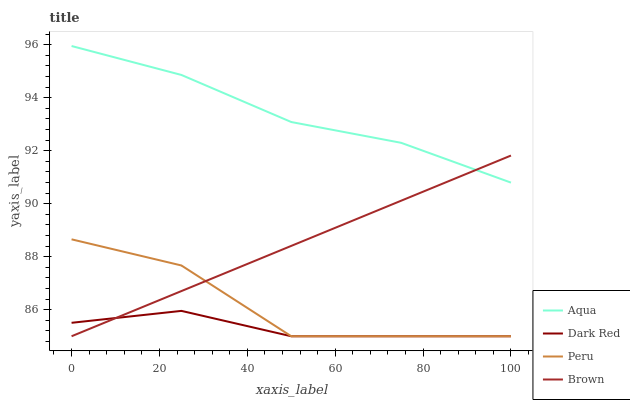Does Dark Red have the minimum area under the curve?
Answer yes or no. Yes. Does Aqua have the maximum area under the curve?
Answer yes or no. Yes. Does Peru have the minimum area under the curve?
Answer yes or no. No. Does Peru have the maximum area under the curve?
Answer yes or no. No. Is Brown the smoothest?
Answer yes or no. Yes. Is Peru the roughest?
Answer yes or no. Yes. Is Aqua the smoothest?
Answer yes or no. No. Is Aqua the roughest?
Answer yes or no. No. Does Dark Red have the lowest value?
Answer yes or no. Yes. Does Aqua have the lowest value?
Answer yes or no. No. Does Aqua have the highest value?
Answer yes or no. Yes. Does Peru have the highest value?
Answer yes or no. No. Is Peru less than Aqua?
Answer yes or no. Yes. Is Aqua greater than Peru?
Answer yes or no. Yes. Does Aqua intersect Brown?
Answer yes or no. Yes. Is Aqua less than Brown?
Answer yes or no. No. Is Aqua greater than Brown?
Answer yes or no. No. Does Peru intersect Aqua?
Answer yes or no. No. 